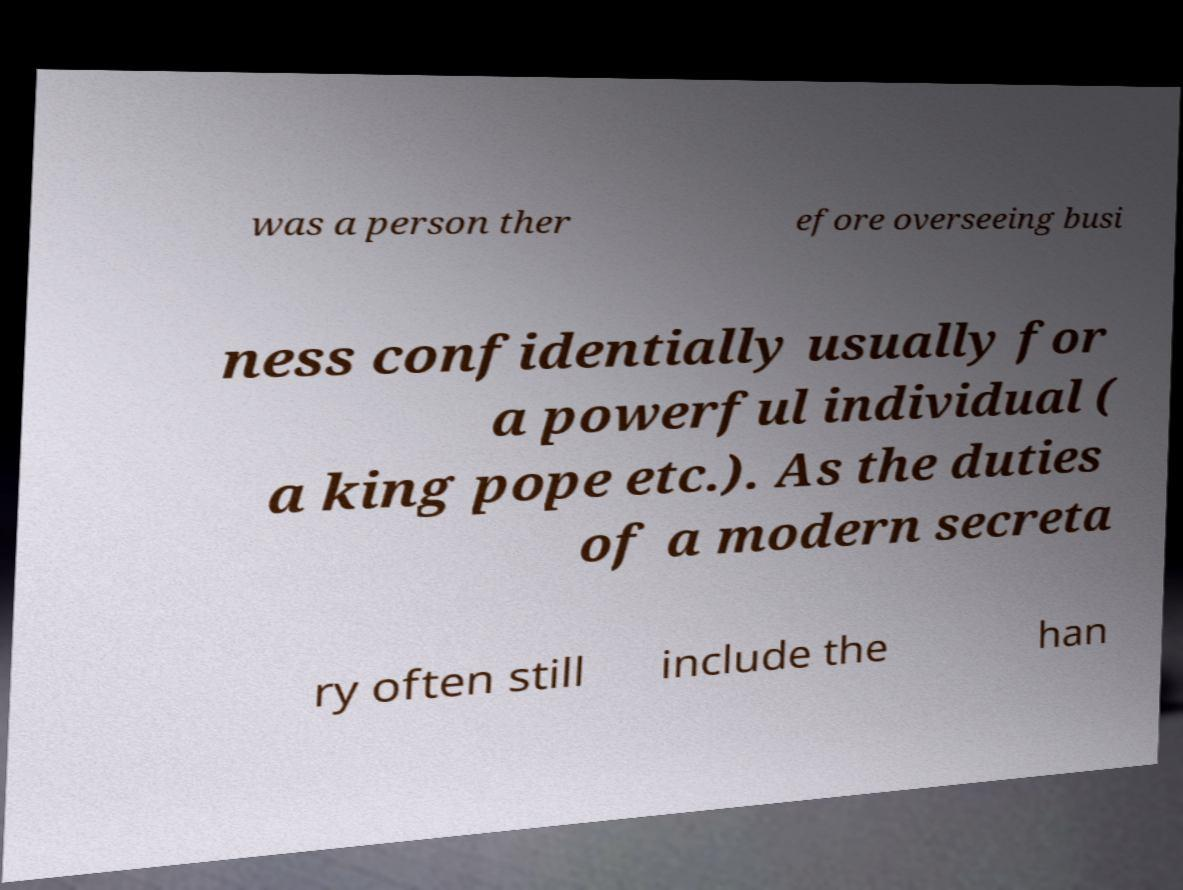For documentation purposes, I need the text within this image transcribed. Could you provide that? was a person ther efore overseeing busi ness confidentially usually for a powerful individual ( a king pope etc.). As the duties of a modern secreta ry often still include the han 